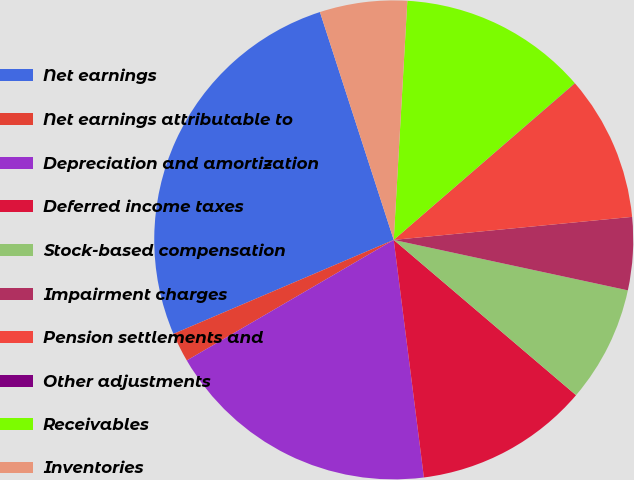Convert chart. <chart><loc_0><loc_0><loc_500><loc_500><pie_chart><fcel>Net earnings<fcel>Net earnings attributable to<fcel>Depreciation and amortization<fcel>Deferred income taxes<fcel>Stock-based compensation<fcel>Impairment charges<fcel>Pension settlements and<fcel>Other adjustments<fcel>Receivables<fcel>Inventories<nl><fcel>26.43%<fcel>1.98%<fcel>18.61%<fcel>11.76%<fcel>7.85%<fcel>4.91%<fcel>9.8%<fcel>0.02%<fcel>12.74%<fcel>5.89%<nl></chart> 